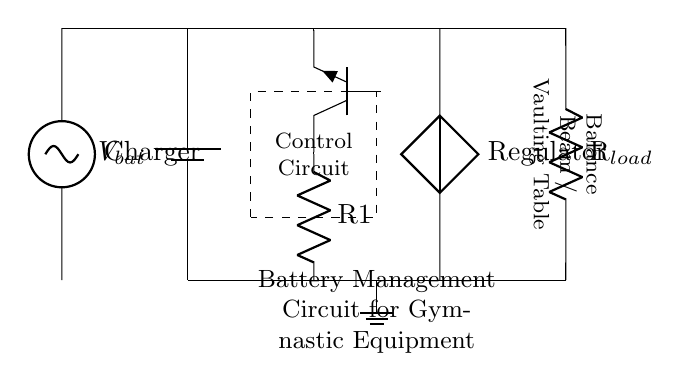What is the main component providing power in the circuit? The battery is the primary power source, indicated by the battery symbol labeled V_bat. It supplies the necessary voltage to the entire circuit.
Answer: Battery What type of regulator is used in this circuit? A voltage regulator is depicted, represented by the symbol labeled "Regulator". It ensures the voltage remains at a stable level regardless of changes in load conditions.
Answer: Voltage regulator How many resistors are present in the circuit? There are two resistors, one labeled R1 in the charging circuit and another labeled R_load in the load section. Both are indicated by the resistor symbols.
Answer: Two What is the function of the control circuit? The control circuit is enclosed within a dashed rectangle, indicating it manages the operation of the charging and power distribution to the load.
Answer: Management Which component connects the charger to the battery? The circuit shows the charger connected to the battery with a power line leading directly into the battery terminal, facilitating charging.
Answer: Charger What type of load is indicated in the circuit? The load is specified as "R_load," indicating a resistor which is emblematic of the load in the gymnastic equipment context being powered in this circuit.
Answer: Balance Beam / Vaulting Table 